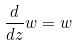Convert formula to latex. <formula><loc_0><loc_0><loc_500><loc_500>\frac { d } { d z } w = w</formula> 